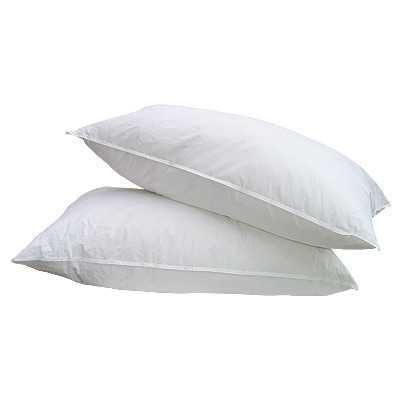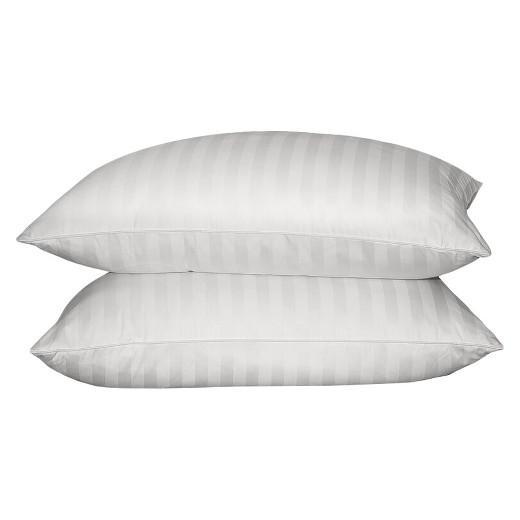The first image is the image on the left, the second image is the image on the right. For the images displayed, is the sentence "Each image contains a stack of two white pillows, and no pillow stacks are sitting on a textured surface." factually correct? Answer yes or no. Yes. 